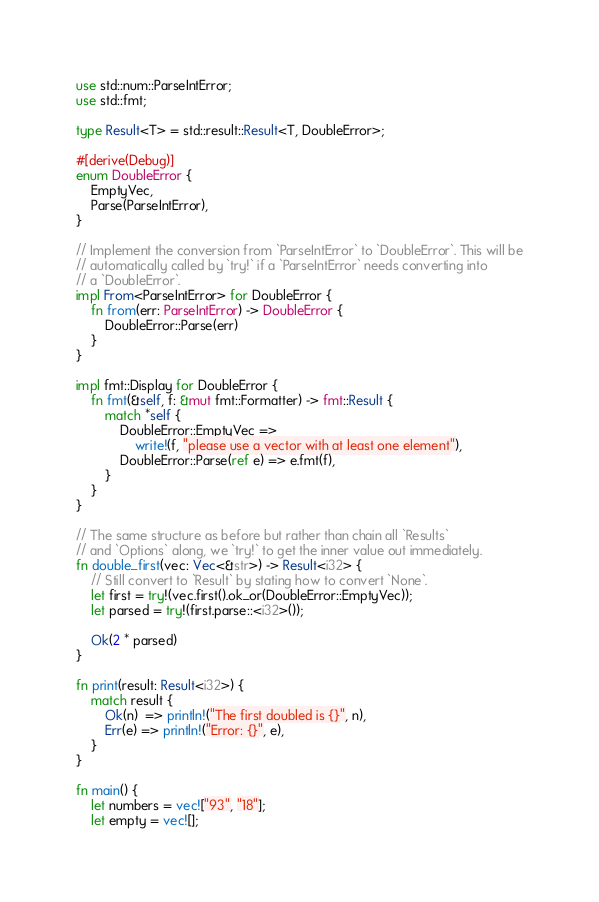<code> <loc_0><loc_0><loc_500><loc_500><_Rust_>use std::num::ParseIntError;
use std::fmt;

type Result<T> = std::result::Result<T, DoubleError>;

#[derive(Debug)]
enum DoubleError {
    EmptyVec,
    Parse(ParseIntError),
}

// Implement the conversion from `ParseIntError` to `DoubleError`. This will be
// automatically called by `try!` if a `ParseIntError` needs converting into
// a `DoubleError`.
impl From<ParseIntError> for DoubleError {
    fn from(err: ParseIntError) -> DoubleError {
        DoubleError::Parse(err)
    }
}

impl fmt::Display for DoubleError {
    fn fmt(&self, f: &mut fmt::Formatter) -> fmt::Result {
        match *self {
            DoubleError::EmptyVec =>
                write!(f, "please use a vector with at least one element"),
            DoubleError::Parse(ref e) => e.fmt(f),
        }
    }
}

// The same structure as before but rather than chain all `Results`
// and `Options` along, we `try!` to get the inner value out immediately.
fn double_first(vec: Vec<&str>) -> Result<i32> {
    // Still convert to `Result` by stating how to convert `None`.
    let first = try!(vec.first().ok_or(DoubleError::EmptyVec));
    let parsed = try!(first.parse::<i32>());

    Ok(2 * parsed)
}

fn print(result: Result<i32>) {
    match result {
        Ok(n)  => println!("The first doubled is {}", n),
        Err(e) => println!("Error: {}", e),
    }
}

fn main() {
    let numbers = vec!["93", "18"];
    let empty = vec![];</code> 